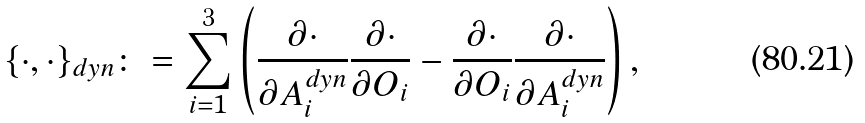Convert formula to latex. <formula><loc_0><loc_0><loc_500><loc_500>\{ \cdot , \cdot \} _ { d y n } \colon = \sum _ { i = 1 } ^ { 3 } \left ( \frac { \partial \cdot } { \partial A _ { i } ^ { d y n } } \frac { \partial \cdot } { \partial O _ { i } } - \frac { \partial \cdot } { \partial O _ { i } } \frac { \partial \cdot } { \partial A _ { i } ^ { d y n } } \right ) ,</formula> 